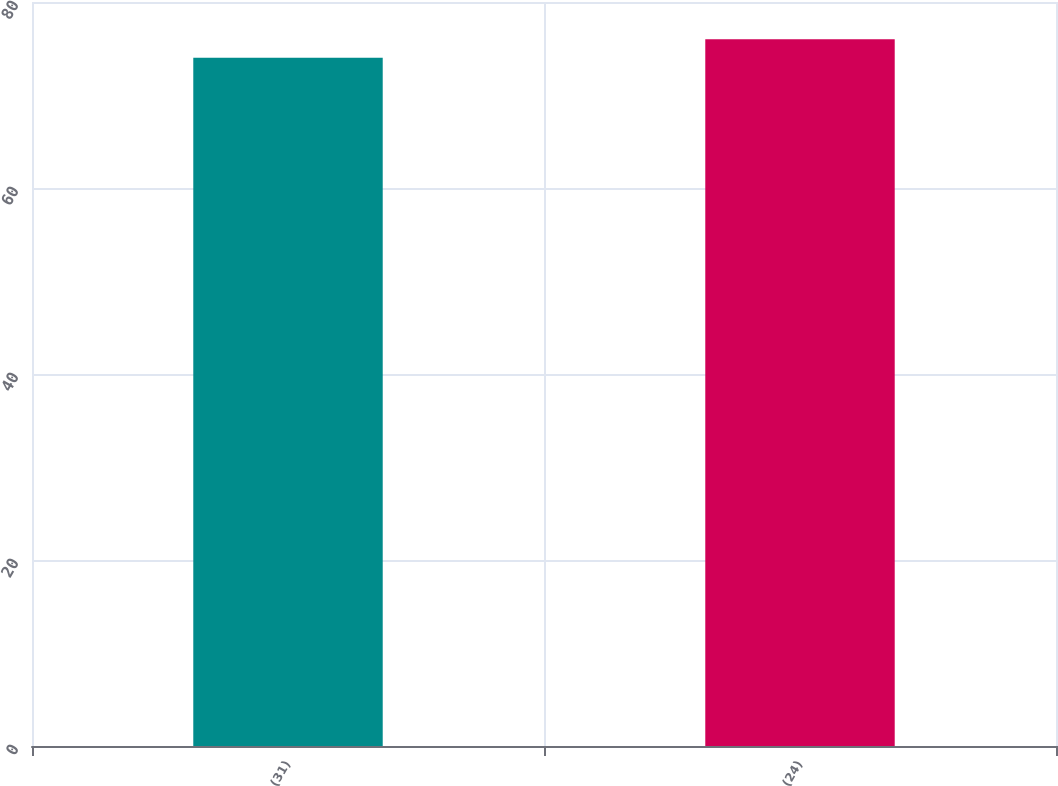Convert chart to OTSL. <chart><loc_0><loc_0><loc_500><loc_500><bar_chart><fcel>(31)<fcel>(24)<nl><fcel>74<fcel>76<nl></chart> 